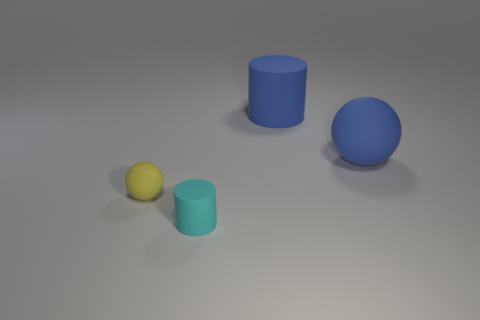Add 3 large gray rubber things. How many objects exist? 7 Add 3 large blue rubber balls. How many large blue rubber balls exist? 4 Subtract 0 purple spheres. How many objects are left? 4 Subtract all large blue rubber cylinders. Subtract all cyan matte spheres. How many objects are left? 3 Add 3 tiny yellow rubber objects. How many tiny yellow rubber objects are left? 4 